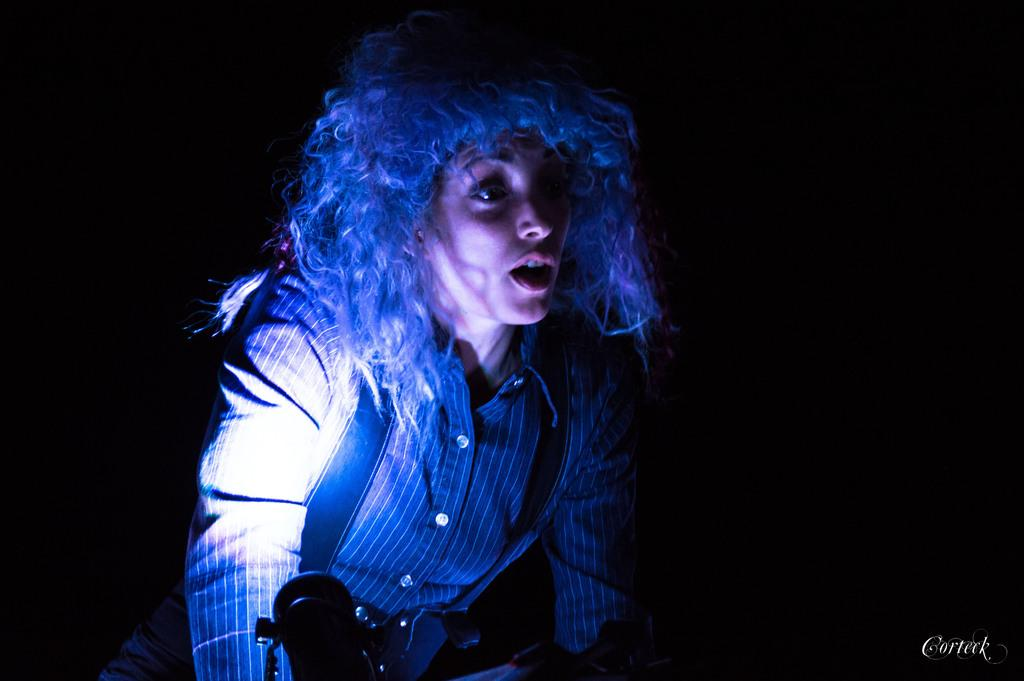Who is the main subject in the image? There is a woman in the image. In which direction is the woman facing? The woman is facing towards the right side. What is the woman doing in the image? The woman is speaking. What color is the background of the image? The background of the image is black. Is there any text visible in the image? Yes, there is some text in the bottom right corner of the image. What type of nut can be seen on the ground in the image? There is no nut or ground present in the image; it features a woman speaking against a black background with text in the bottom right corner. 